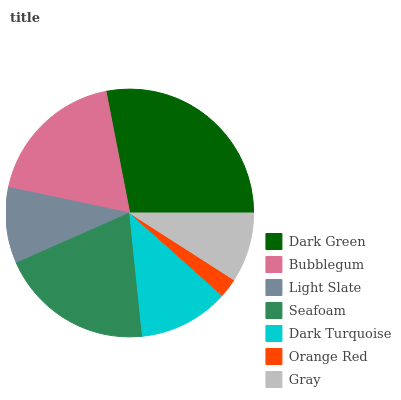Is Orange Red the minimum?
Answer yes or no. Yes. Is Dark Green the maximum?
Answer yes or no. Yes. Is Bubblegum the minimum?
Answer yes or no. No. Is Bubblegum the maximum?
Answer yes or no. No. Is Dark Green greater than Bubblegum?
Answer yes or no. Yes. Is Bubblegum less than Dark Green?
Answer yes or no. Yes. Is Bubblegum greater than Dark Green?
Answer yes or no. No. Is Dark Green less than Bubblegum?
Answer yes or no. No. Is Dark Turquoise the high median?
Answer yes or no. Yes. Is Dark Turquoise the low median?
Answer yes or no. Yes. Is Orange Red the high median?
Answer yes or no. No. Is Seafoam the low median?
Answer yes or no. No. 